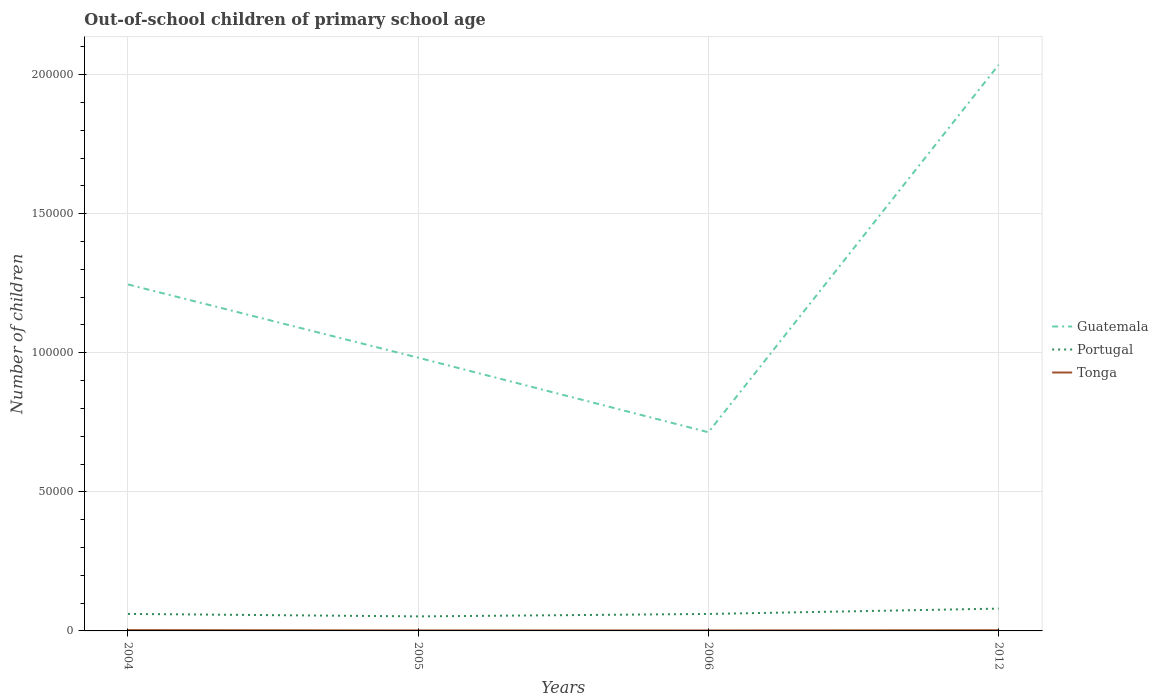Is the number of lines equal to the number of legend labels?
Your answer should be compact. Yes. Across all years, what is the maximum number of out-of-school children in Guatemala?
Your answer should be very brief. 7.14e+04. In which year was the number of out-of-school children in Tonga maximum?
Your answer should be compact. 2006. What is the total number of out-of-school children in Guatemala in the graph?
Your answer should be compact. -1.05e+05. What is the difference between the highest and the second highest number of out-of-school children in Tonga?
Your response must be concise. 119. What is the difference between the highest and the lowest number of out-of-school children in Tonga?
Ensure brevity in your answer.  2. How many lines are there?
Offer a very short reply. 3. Are the values on the major ticks of Y-axis written in scientific E-notation?
Keep it short and to the point. No. Does the graph contain grids?
Offer a terse response. Yes. How many legend labels are there?
Keep it short and to the point. 3. What is the title of the graph?
Your answer should be very brief. Out-of-school children of primary school age. What is the label or title of the X-axis?
Make the answer very short. Years. What is the label or title of the Y-axis?
Your answer should be compact. Number of children. What is the Number of children of Guatemala in 2004?
Make the answer very short. 1.25e+05. What is the Number of children of Portugal in 2004?
Make the answer very short. 6119. What is the Number of children of Tonga in 2004?
Offer a terse response. 287. What is the Number of children in Guatemala in 2005?
Keep it short and to the point. 9.82e+04. What is the Number of children in Portugal in 2005?
Provide a succinct answer. 5223. What is the Number of children in Tonga in 2005?
Your answer should be compact. 178. What is the Number of children in Guatemala in 2006?
Your answer should be very brief. 7.14e+04. What is the Number of children in Portugal in 2006?
Your answer should be very brief. 6100. What is the Number of children of Tonga in 2006?
Your answer should be compact. 168. What is the Number of children in Guatemala in 2012?
Your response must be concise. 2.04e+05. What is the Number of children in Portugal in 2012?
Your response must be concise. 8020. What is the Number of children of Tonga in 2012?
Ensure brevity in your answer.  247. Across all years, what is the maximum Number of children in Guatemala?
Offer a terse response. 2.04e+05. Across all years, what is the maximum Number of children of Portugal?
Offer a very short reply. 8020. Across all years, what is the maximum Number of children in Tonga?
Provide a short and direct response. 287. Across all years, what is the minimum Number of children in Guatemala?
Provide a succinct answer. 7.14e+04. Across all years, what is the minimum Number of children of Portugal?
Offer a terse response. 5223. Across all years, what is the minimum Number of children of Tonga?
Your answer should be compact. 168. What is the total Number of children in Guatemala in the graph?
Make the answer very short. 4.98e+05. What is the total Number of children in Portugal in the graph?
Provide a short and direct response. 2.55e+04. What is the total Number of children of Tonga in the graph?
Offer a terse response. 880. What is the difference between the Number of children in Guatemala in 2004 and that in 2005?
Provide a short and direct response. 2.63e+04. What is the difference between the Number of children of Portugal in 2004 and that in 2005?
Offer a terse response. 896. What is the difference between the Number of children of Tonga in 2004 and that in 2005?
Ensure brevity in your answer.  109. What is the difference between the Number of children in Guatemala in 2004 and that in 2006?
Your response must be concise. 5.31e+04. What is the difference between the Number of children in Tonga in 2004 and that in 2006?
Offer a terse response. 119. What is the difference between the Number of children in Guatemala in 2004 and that in 2012?
Provide a succinct answer. -7.90e+04. What is the difference between the Number of children of Portugal in 2004 and that in 2012?
Ensure brevity in your answer.  -1901. What is the difference between the Number of children of Tonga in 2004 and that in 2012?
Make the answer very short. 40. What is the difference between the Number of children in Guatemala in 2005 and that in 2006?
Offer a terse response. 2.68e+04. What is the difference between the Number of children of Portugal in 2005 and that in 2006?
Provide a succinct answer. -877. What is the difference between the Number of children of Tonga in 2005 and that in 2006?
Offer a terse response. 10. What is the difference between the Number of children of Guatemala in 2005 and that in 2012?
Your response must be concise. -1.05e+05. What is the difference between the Number of children in Portugal in 2005 and that in 2012?
Your answer should be very brief. -2797. What is the difference between the Number of children in Tonga in 2005 and that in 2012?
Keep it short and to the point. -69. What is the difference between the Number of children of Guatemala in 2006 and that in 2012?
Keep it short and to the point. -1.32e+05. What is the difference between the Number of children in Portugal in 2006 and that in 2012?
Make the answer very short. -1920. What is the difference between the Number of children of Tonga in 2006 and that in 2012?
Your answer should be compact. -79. What is the difference between the Number of children in Guatemala in 2004 and the Number of children in Portugal in 2005?
Ensure brevity in your answer.  1.19e+05. What is the difference between the Number of children in Guatemala in 2004 and the Number of children in Tonga in 2005?
Ensure brevity in your answer.  1.24e+05. What is the difference between the Number of children of Portugal in 2004 and the Number of children of Tonga in 2005?
Make the answer very short. 5941. What is the difference between the Number of children of Guatemala in 2004 and the Number of children of Portugal in 2006?
Offer a very short reply. 1.18e+05. What is the difference between the Number of children of Guatemala in 2004 and the Number of children of Tonga in 2006?
Provide a short and direct response. 1.24e+05. What is the difference between the Number of children of Portugal in 2004 and the Number of children of Tonga in 2006?
Provide a short and direct response. 5951. What is the difference between the Number of children in Guatemala in 2004 and the Number of children in Portugal in 2012?
Offer a terse response. 1.17e+05. What is the difference between the Number of children in Guatemala in 2004 and the Number of children in Tonga in 2012?
Your answer should be very brief. 1.24e+05. What is the difference between the Number of children of Portugal in 2004 and the Number of children of Tonga in 2012?
Keep it short and to the point. 5872. What is the difference between the Number of children in Guatemala in 2005 and the Number of children in Portugal in 2006?
Provide a succinct answer. 9.21e+04. What is the difference between the Number of children of Guatemala in 2005 and the Number of children of Tonga in 2006?
Offer a terse response. 9.81e+04. What is the difference between the Number of children of Portugal in 2005 and the Number of children of Tonga in 2006?
Your answer should be compact. 5055. What is the difference between the Number of children in Guatemala in 2005 and the Number of children in Portugal in 2012?
Offer a very short reply. 9.02e+04. What is the difference between the Number of children of Guatemala in 2005 and the Number of children of Tonga in 2012?
Give a very brief answer. 9.80e+04. What is the difference between the Number of children in Portugal in 2005 and the Number of children in Tonga in 2012?
Ensure brevity in your answer.  4976. What is the difference between the Number of children in Guatemala in 2006 and the Number of children in Portugal in 2012?
Offer a terse response. 6.34e+04. What is the difference between the Number of children in Guatemala in 2006 and the Number of children in Tonga in 2012?
Give a very brief answer. 7.12e+04. What is the difference between the Number of children in Portugal in 2006 and the Number of children in Tonga in 2012?
Keep it short and to the point. 5853. What is the average Number of children in Guatemala per year?
Provide a succinct answer. 1.24e+05. What is the average Number of children in Portugal per year?
Give a very brief answer. 6365.5. What is the average Number of children in Tonga per year?
Provide a succinct answer. 220. In the year 2004, what is the difference between the Number of children in Guatemala and Number of children in Portugal?
Keep it short and to the point. 1.18e+05. In the year 2004, what is the difference between the Number of children in Guatemala and Number of children in Tonga?
Give a very brief answer. 1.24e+05. In the year 2004, what is the difference between the Number of children in Portugal and Number of children in Tonga?
Provide a short and direct response. 5832. In the year 2005, what is the difference between the Number of children of Guatemala and Number of children of Portugal?
Make the answer very short. 9.30e+04. In the year 2005, what is the difference between the Number of children of Guatemala and Number of children of Tonga?
Your answer should be compact. 9.81e+04. In the year 2005, what is the difference between the Number of children of Portugal and Number of children of Tonga?
Provide a short and direct response. 5045. In the year 2006, what is the difference between the Number of children of Guatemala and Number of children of Portugal?
Offer a terse response. 6.53e+04. In the year 2006, what is the difference between the Number of children in Guatemala and Number of children in Tonga?
Provide a short and direct response. 7.13e+04. In the year 2006, what is the difference between the Number of children in Portugal and Number of children in Tonga?
Provide a short and direct response. 5932. In the year 2012, what is the difference between the Number of children of Guatemala and Number of children of Portugal?
Ensure brevity in your answer.  1.96e+05. In the year 2012, what is the difference between the Number of children of Guatemala and Number of children of Tonga?
Keep it short and to the point. 2.03e+05. In the year 2012, what is the difference between the Number of children in Portugal and Number of children in Tonga?
Your answer should be compact. 7773. What is the ratio of the Number of children in Guatemala in 2004 to that in 2005?
Your response must be concise. 1.27. What is the ratio of the Number of children of Portugal in 2004 to that in 2005?
Ensure brevity in your answer.  1.17. What is the ratio of the Number of children in Tonga in 2004 to that in 2005?
Ensure brevity in your answer.  1.61. What is the ratio of the Number of children in Guatemala in 2004 to that in 2006?
Provide a succinct answer. 1.74. What is the ratio of the Number of children in Tonga in 2004 to that in 2006?
Offer a very short reply. 1.71. What is the ratio of the Number of children of Guatemala in 2004 to that in 2012?
Offer a very short reply. 0.61. What is the ratio of the Number of children in Portugal in 2004 to that in 2012?
Keep it short and to the point. 0.76. What is the ratio of the Number of children in Tonga in 2004 to that in 2012?
Provide a succinct answer. 1.16. What is the ratio of the Number of children in Guatemala in 2005 to that in 2006?
Your answer should be compact. 1.38. What is the ratio of the Number of children in Portugal in 2005 to that in 2006?
Provide a short and direct response. 0.86. What is the ratio of the Number of children in Tonga in 2005 to that in 2006?
Make the answer very short. 1.06. What is the ratio of the Number of children of Guatemala in 2005 to that in 2012?
Your response must be concise. 0.48. What is the ratio of the Number of children of Portugal in 2005 to that in 2012?
Your response must be concise. 0.65. What is the ratio of the Number of children in Tonga in 2005 to that in 2012?
Offer a very short reply. 0.72. What is the ratio of the Number of children of Guatemala in 2006 to that in 2012?
Offer a terse response. 0.35. What is the ratio of the Number of children in Portugal in 2006 to that in 2012?
Your answer should be very brief. 0.76. What is the ratio of the Number of children of Tonga in 2006 to that in 2012?
Ensure brevity in your answer.  0.68. What is the difference between the highest and the second highest Number of children in Guatemala?
Provide a succinct answer. 7.90e+04. What is the difference between the highest and the second highest Number of children in Portugal?
Give a very brief answer. 1901. What is the difference between the highest and the second highest Number of children in Tonga?
Your answer should be compact. 40. What is the difference between the highest and the lowest Number of children of Guatemala?
Your answer should be compact. 1.32e+05. What is the difference between the highest and the lowest Number of children in Portugal?
Offer a terse response. 2797. What is the difference between the highest and the lowest Number of children of Tonga?
Ensure brevity in your answer.  119. 